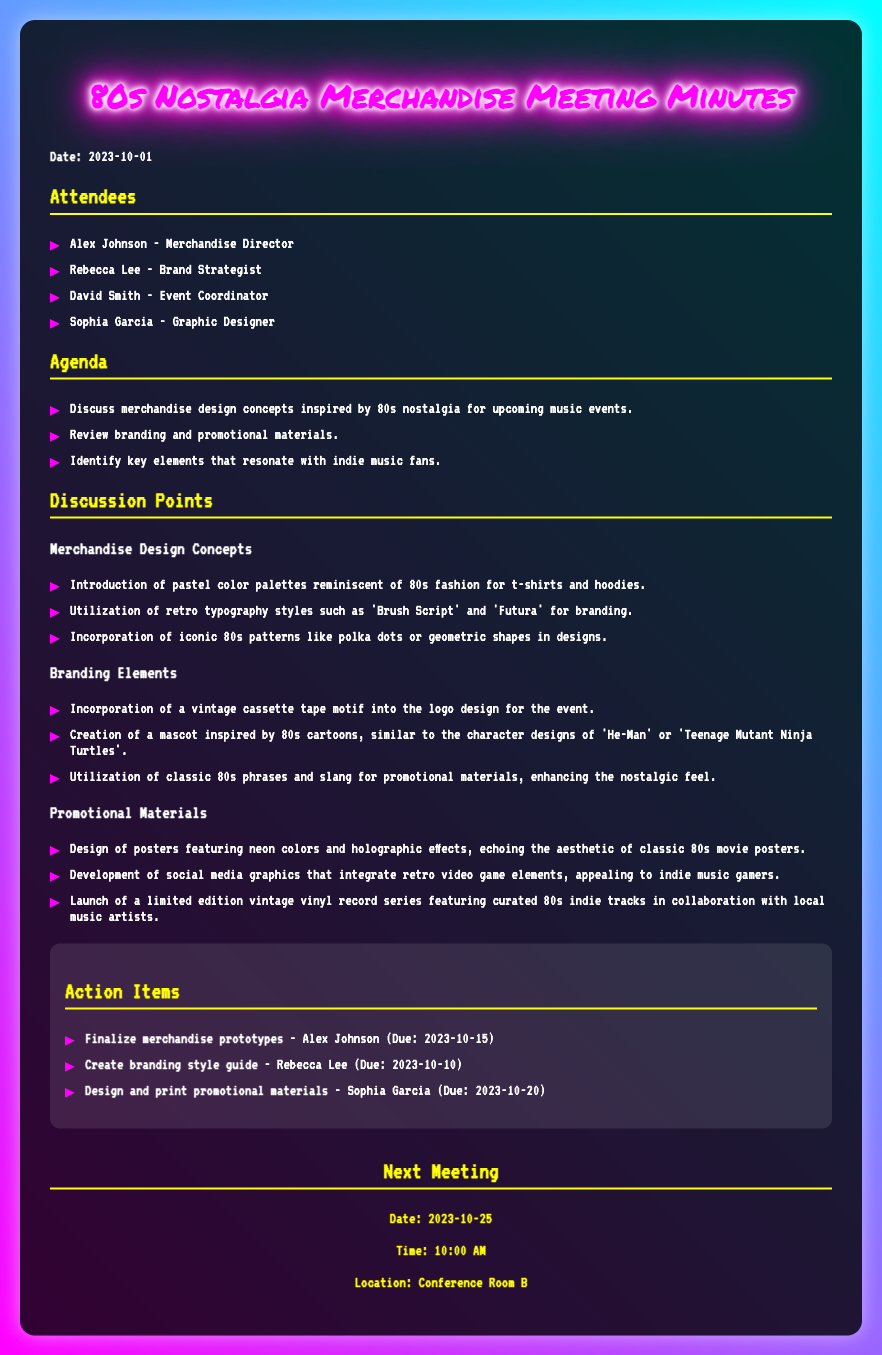what is the date of the meeting? The date of the meeting is explicitly stated in the document as "2023-10-01".
Answer: 2023-10-01 who is the Merchandise Director? The document lists Alex Johnson as the Merchandise Director.
Answer: Alex Johnson what color palettes are introduced for the merchandise? The meeting minutes mention "pastel color palettes" as the introduced colors for the merchandise.
Answer: pastel color palettes what is one of the retro typography styles mentioned? The document lists 'Brush Script' as a retro typography style being utilized in the branding.
Answer: Brush Script when is the due date for finalizing merchandise prototypes? The due date for finalizing merchandise prototypes is given as "2023-10-15".
Answer: 2023-10-15 what is the mascot inspired by? The mascot creation is inspired by "80s cartoons", specifically influencing from 'He-Man' or 'Teenage Mutant Ninja Turtles'.
Answer: 80s cartoons how many attendees were listed in the meeting minutes? The document lists four attendees present during the meeting.
Answer: four what is highlighted as a key element in branding? The incorporation of a "vintage cassette tape motif" is highlighted in the branding elements discussed.
Answer: vintage cassette tape motif when is the next meeting scheduled? The next meeting is scheduled for "2023-10-25".
Answer: 2023-10-25 